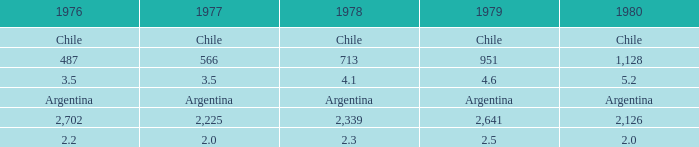What stands for 1976 when 1980 is equivalent to 2.2. 